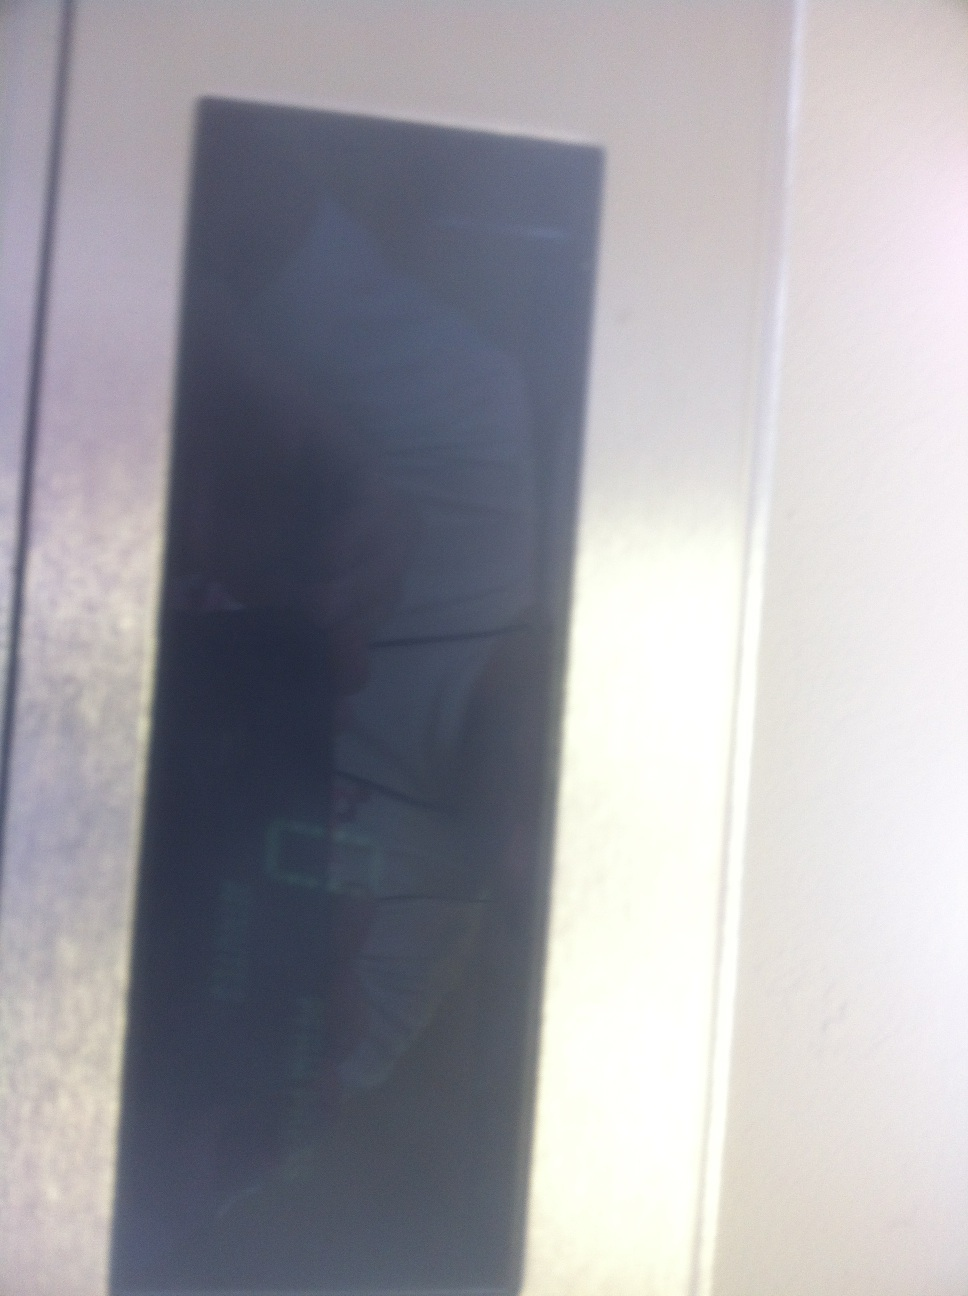Imagine this display can tell the future. What would it show? If this display could tell the future, it might show an array of fascinating and mysterious images – a glimpse of upcoming technological advancements, significant global events, personal life milestones, or potential discoveries. One moment it could project the unveiling of a groundbreaking medical treatment; the next, it might indicate a pivotal historical moment unfolding. Each piece of data would be shrouded in a mix of cryptic numbers and symbols, sparking curiosity and intrigue about the paths ahead. 